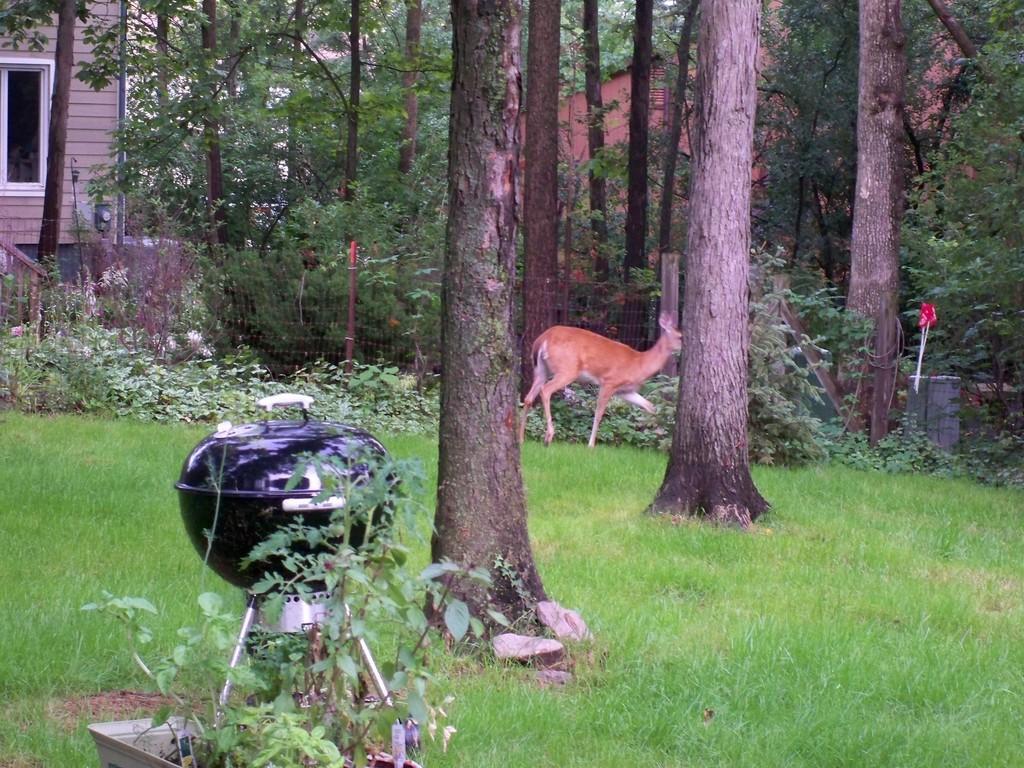Please provide a concise description of this image. In this image I can see the black color bowl on the steel stand. It is on the ground. To the side I can see an animal which is in brown color. To the side of the animal I can see the railing. There are many trees around the animal. In the background I can see the building and the hut. 